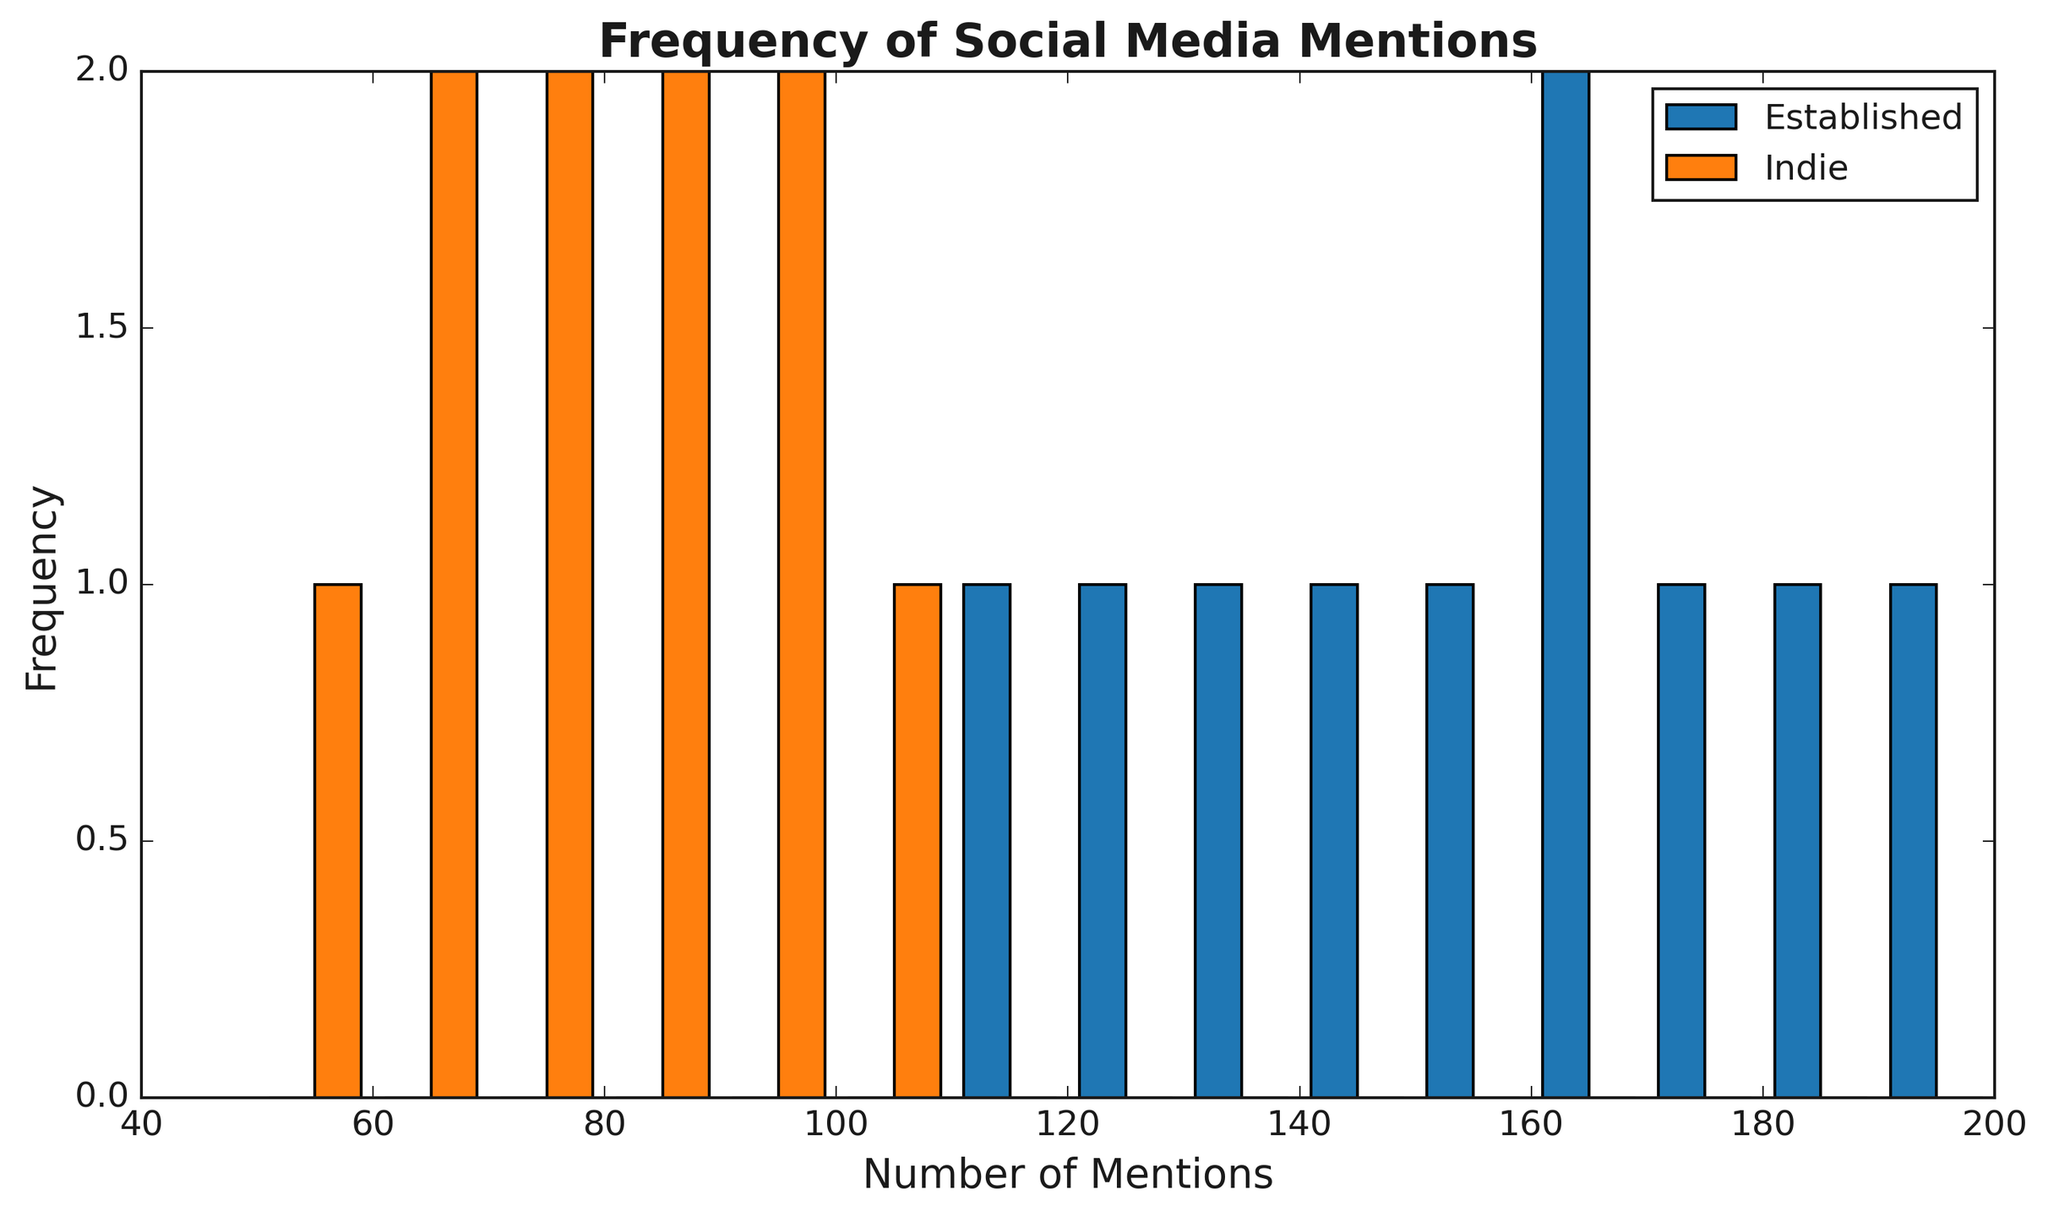How many bins are used in the histogram? The histogram displays bars grouped into intervals (bins) of 10 mentions each, from 50 to 200. Thus, the number of bins is calculated as (200 - 50) / 10 = 15 bins.
Answer: 15 Which group has a higher peak frequency of mentions? The histogram shows the highest bar for each group. The highest peak for established musicians is around the 160 mentions bin, and the highest for indie musicians is around the 90 mentions bin. The height of the bar at 160 mentions for the established musicians is higher.
Answer: Established Considering the bin with 160 mentions, how does the frequency of established musicians compare to indie musicians? The histogram bar at the bin with 160 mentions shows the frequency of mentions. For established musicians, it is higher than for indie musicians, where it appears very close to zero.
Answer: Higher What ranges of mentions are most common for indie musicians? The histogram shows the height of the bars for indie musicians. The highest bars for indie musicians appear between 50-100 mentions, indicating this range is most common.
Answer: 50-100 What is the difference in the number of mentions between the highest bars for established and indie musicians? The highest bar for established musicians is around the 160 mentions bin, whereas for indie musicians, it is around the 90 mentions bin. The difference is calculated as 160 - 90 = 70 mentions.
Answer: 70 How frequently do established musicians receive mentions in the 110-140 range compared to indie musicians? In the histogram, the bars in the bins 110-140 mentions show a higher frequency for established musicians than for indie musicians.
Answer: More frequently Which group shows more variability in the frequency of mentions across different bins? To assess variability, we compare the spread of the histogram. Established musicians' mentions are spread over a wider range of bins from 110 to 190, while indie musicians' mentions are concentrated from 50 to 100, showing greater variability for established musicians.
Answer: Established What color represents indie musicians in the histogram? The histogram uses different colors for each group. Indie musicians are represented by the orange bars.
Answer: Orange 